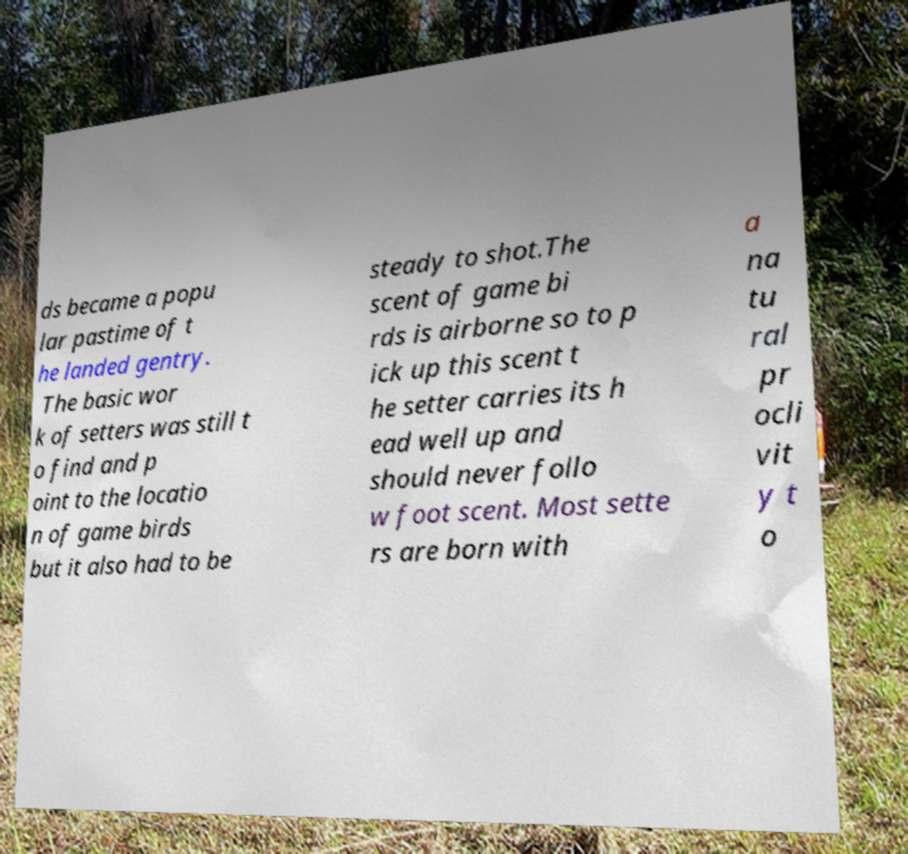Please read and relay the text visible in this image. What does it say? ds became a popu lar pastime of t he landed gentry. The basic wor k of setters was still t o find and p oint to the locatio n of game birds but it also had to be steady to shot.The scent of game bi rds is airborne so to p ick up this scent t he setter carries its h ead well up and should never follo w foot scent. Most sette rs are born with a na tu ral pr ocli vit y t o 